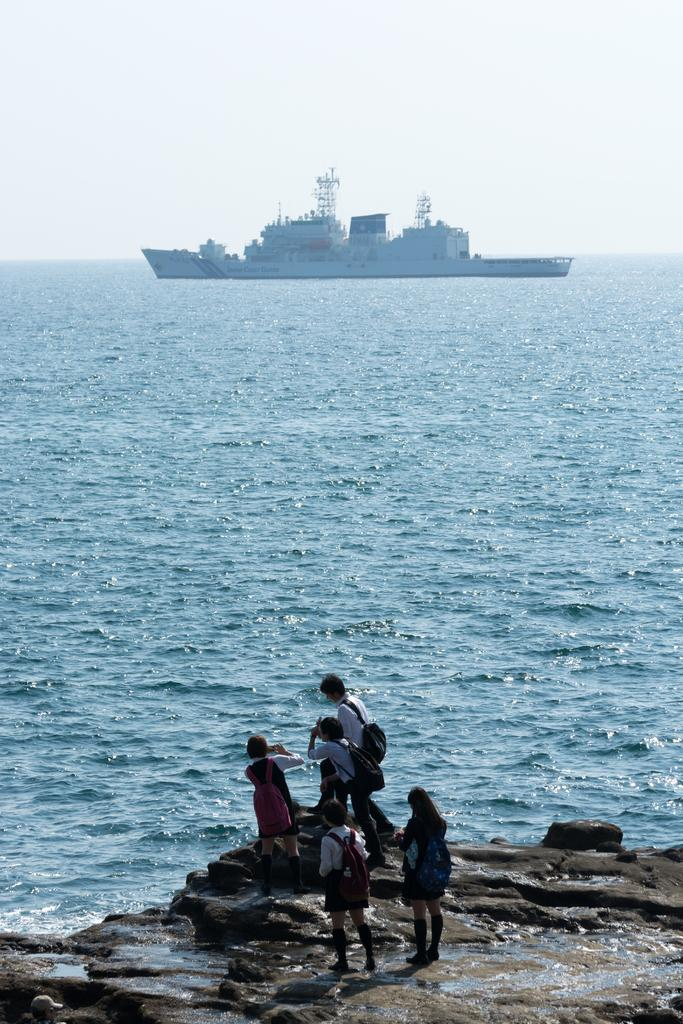What can be seen in the front of the image? There are people standing in the front of the image. What is located at the bottom of the image? There is water visible at the bottom of the image. What is present in the water? There is a ship in the water. What is visible at the top of the image? The sky is visible at the top of the image. What type of patch is being sewn onto the ship's sail in the image? There is no patch being sewn onto the ship's sail in the image; it is not mentioned in the provided facts. How do the people in the image react to the ongoing battle? There is no battle present in the image, so it is not possible to determine how the people might react. 